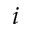Convert formula to latex. <formula><loc_0><loc_0><loc_500><loc_500>i</formula> 